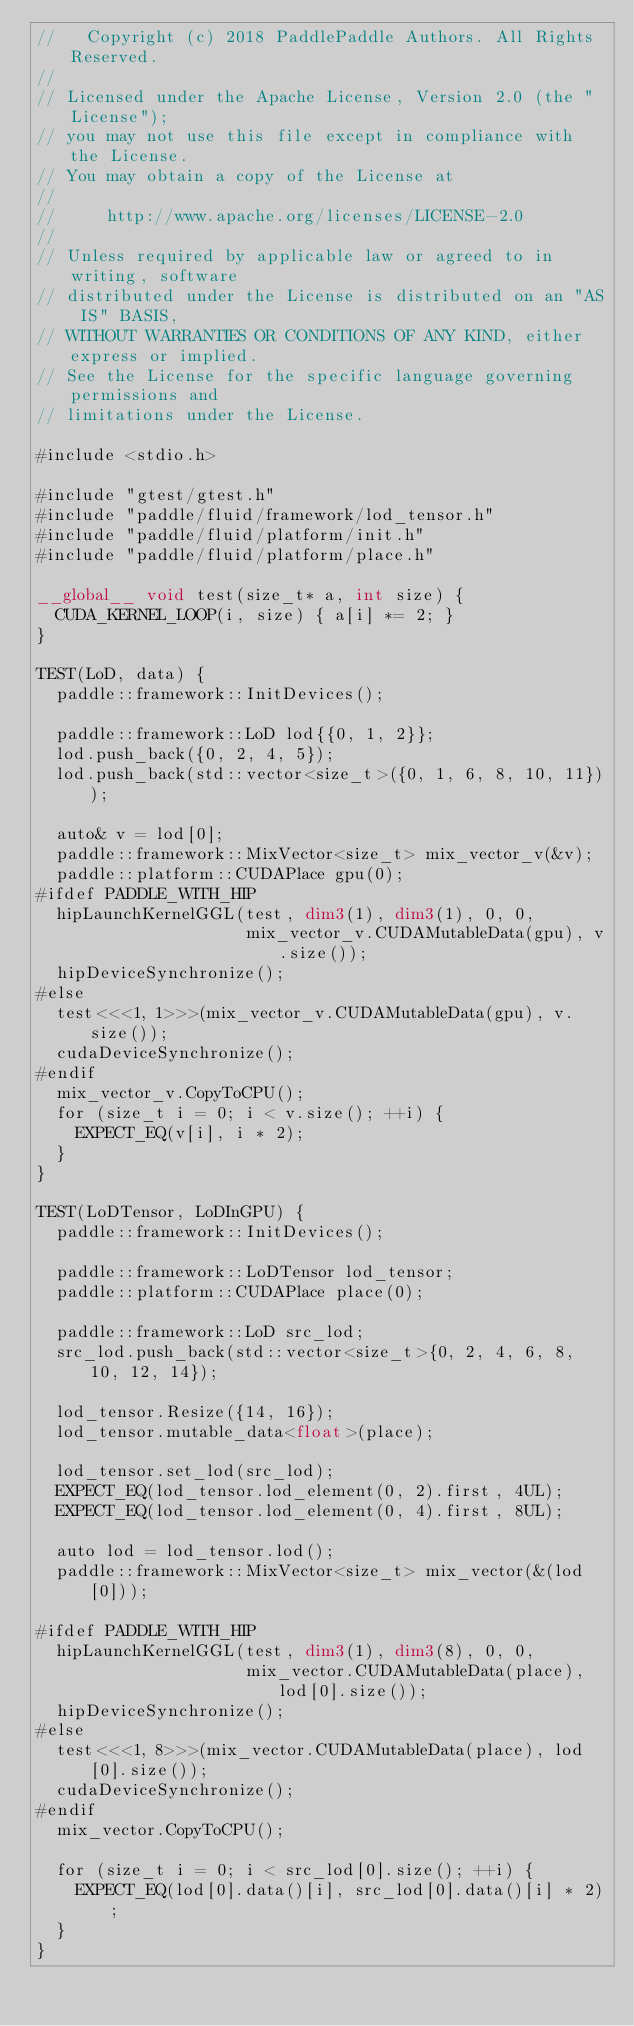Convert code to text. <code><loc_0><loc_0><loc_500><loc_500><_Cuda_>//   Copyright (c) 2018 PaddlePaddle Authors. All Rights Reserved.
//
// Licensed under the Apache License, Version 2.0 (the "License");
// you may not use this file except in compliance with the License.
// You may obtain a copy of the License at
//
//     http://www.apache.org/licenses/LICENSE-2.0
//
// Unless required by applicable law or agreed to in writing, software
// distributed under the License is distributed on an "AS IS" BASIS,
// WITHOUT WARRANTIES OR CONDITIONS OF ANY KIND, either express or implied.
// See the License for the specific language governing permissions and
// limitations under the License.

#include <stdio.h>

#include "gtest/gtest.h"
#include "paddle/fluid/framework/lod_tensor.h"
#include "paddle/fluid/platform/init.h"
#include "paddle/fluid/platform/place.h"

__global__ void test(size_t* a, int size) {
  CUDA_KERNEL_LOOP(i, size) { a[i] *= 2; }
}

TEST(LoD, data) {
  paddle::framework::InitDevices();

  paddle::framework::LoD lod{{0, 1, 2}};
  lod.push_back({0, 2, 4, 5});
  lod.push_back(std::vector<size_t>({0, 1, 6, 8, 10, 11}));

  auto& v = lod[0];
  paddle::framework::MixVector<size_t> mix_vector_v(&v);
  paddle::platform::CUDAPlace gpu(0);
#ifdef PADDLE_WITH_HIP
  hipLaunchKernelGGL(test, dim3(1), dim3(1), 0, 0,
                     mix_vector_v.CUDAMutableData(gpu), v.size());
  hipDeviceSynchronize();
#else
  test<<<1, 1>>>(mix_vector_v.CUDAMutableData(gpu), v.size());
  cudaDeviceSynchronize();
#endif
  mix_vector_v.CopyToCPU();
  for (size_t i = 0; i < v.size(); ++i) {
    EXPECT_EQ(v[i], i * 2);
  }
}

TEST(LoDTensor, LoDInGPU) {
  paddle::framework::InitDevices();

  paddle::framework::LoDTensor lod_tensor;
  paddle::platform::CUDAPlace place(0);

  paddle::framework::LoD src_lod;
  src_lod.push_back(std::vector<size_t>{0, 2, 4, 6, 8, 10, 12, 14});

  lod_tensor.Resize({14, 16});
  lod_tensor.mutable_data<float>(place);

  lod_tensor.set_lod(src_lod);
  EXPECT_EQ(lod_tensor.lod_element(0, 2).first, 4UL);
  EXPECT_EQ(lod_tensor.lod_element(0, 4).first, 8UL);

  auto lod = lod_tensor.lod();
  paddle::framework::MixVector<size_t> mix_vector(&(lod[0]));

#ifdef PADDLE_WITH_HIP
  hipLaunchKernelGGL(test, dim3(1), dim3(8), 0, 0,
                     mix_vector.CUDAMutableData(place), lod[0].size());
  hipDeviceSynchronize();
#else
  test<<<1, 8>>>(mix_vector.CUDAMutableData(place), lod[0].size());
  cudaDeviceSynchronize();
#endif
  mix_vector.CopyToCPU();

  for (size_t i = 0; i < src_lod[0].size(); ++i) {
    EXPECT_EQ(lod[0].data()[i], src_lod[0].data()[i] * 2);
  }
}
</code> 